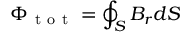Convert formula to latex. <formula><loc_0><loc_0><loc_500><loc_500>\Phi _ { t o t } = \oint _ { S } B _ { r } d S</formula> 